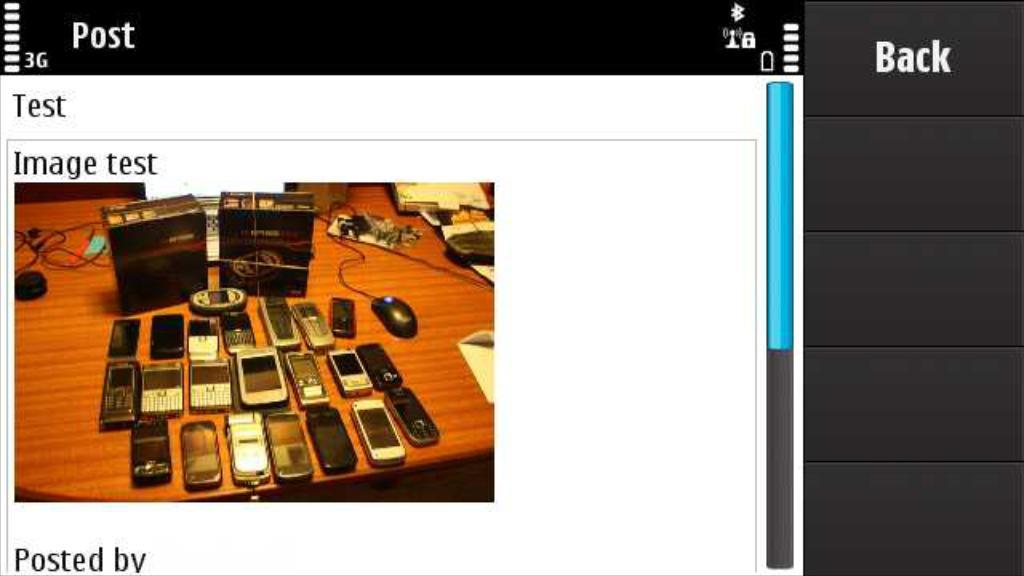<image>
Create a compact narrative representing the image presented. A screen has an image test and shows several cell phones. 